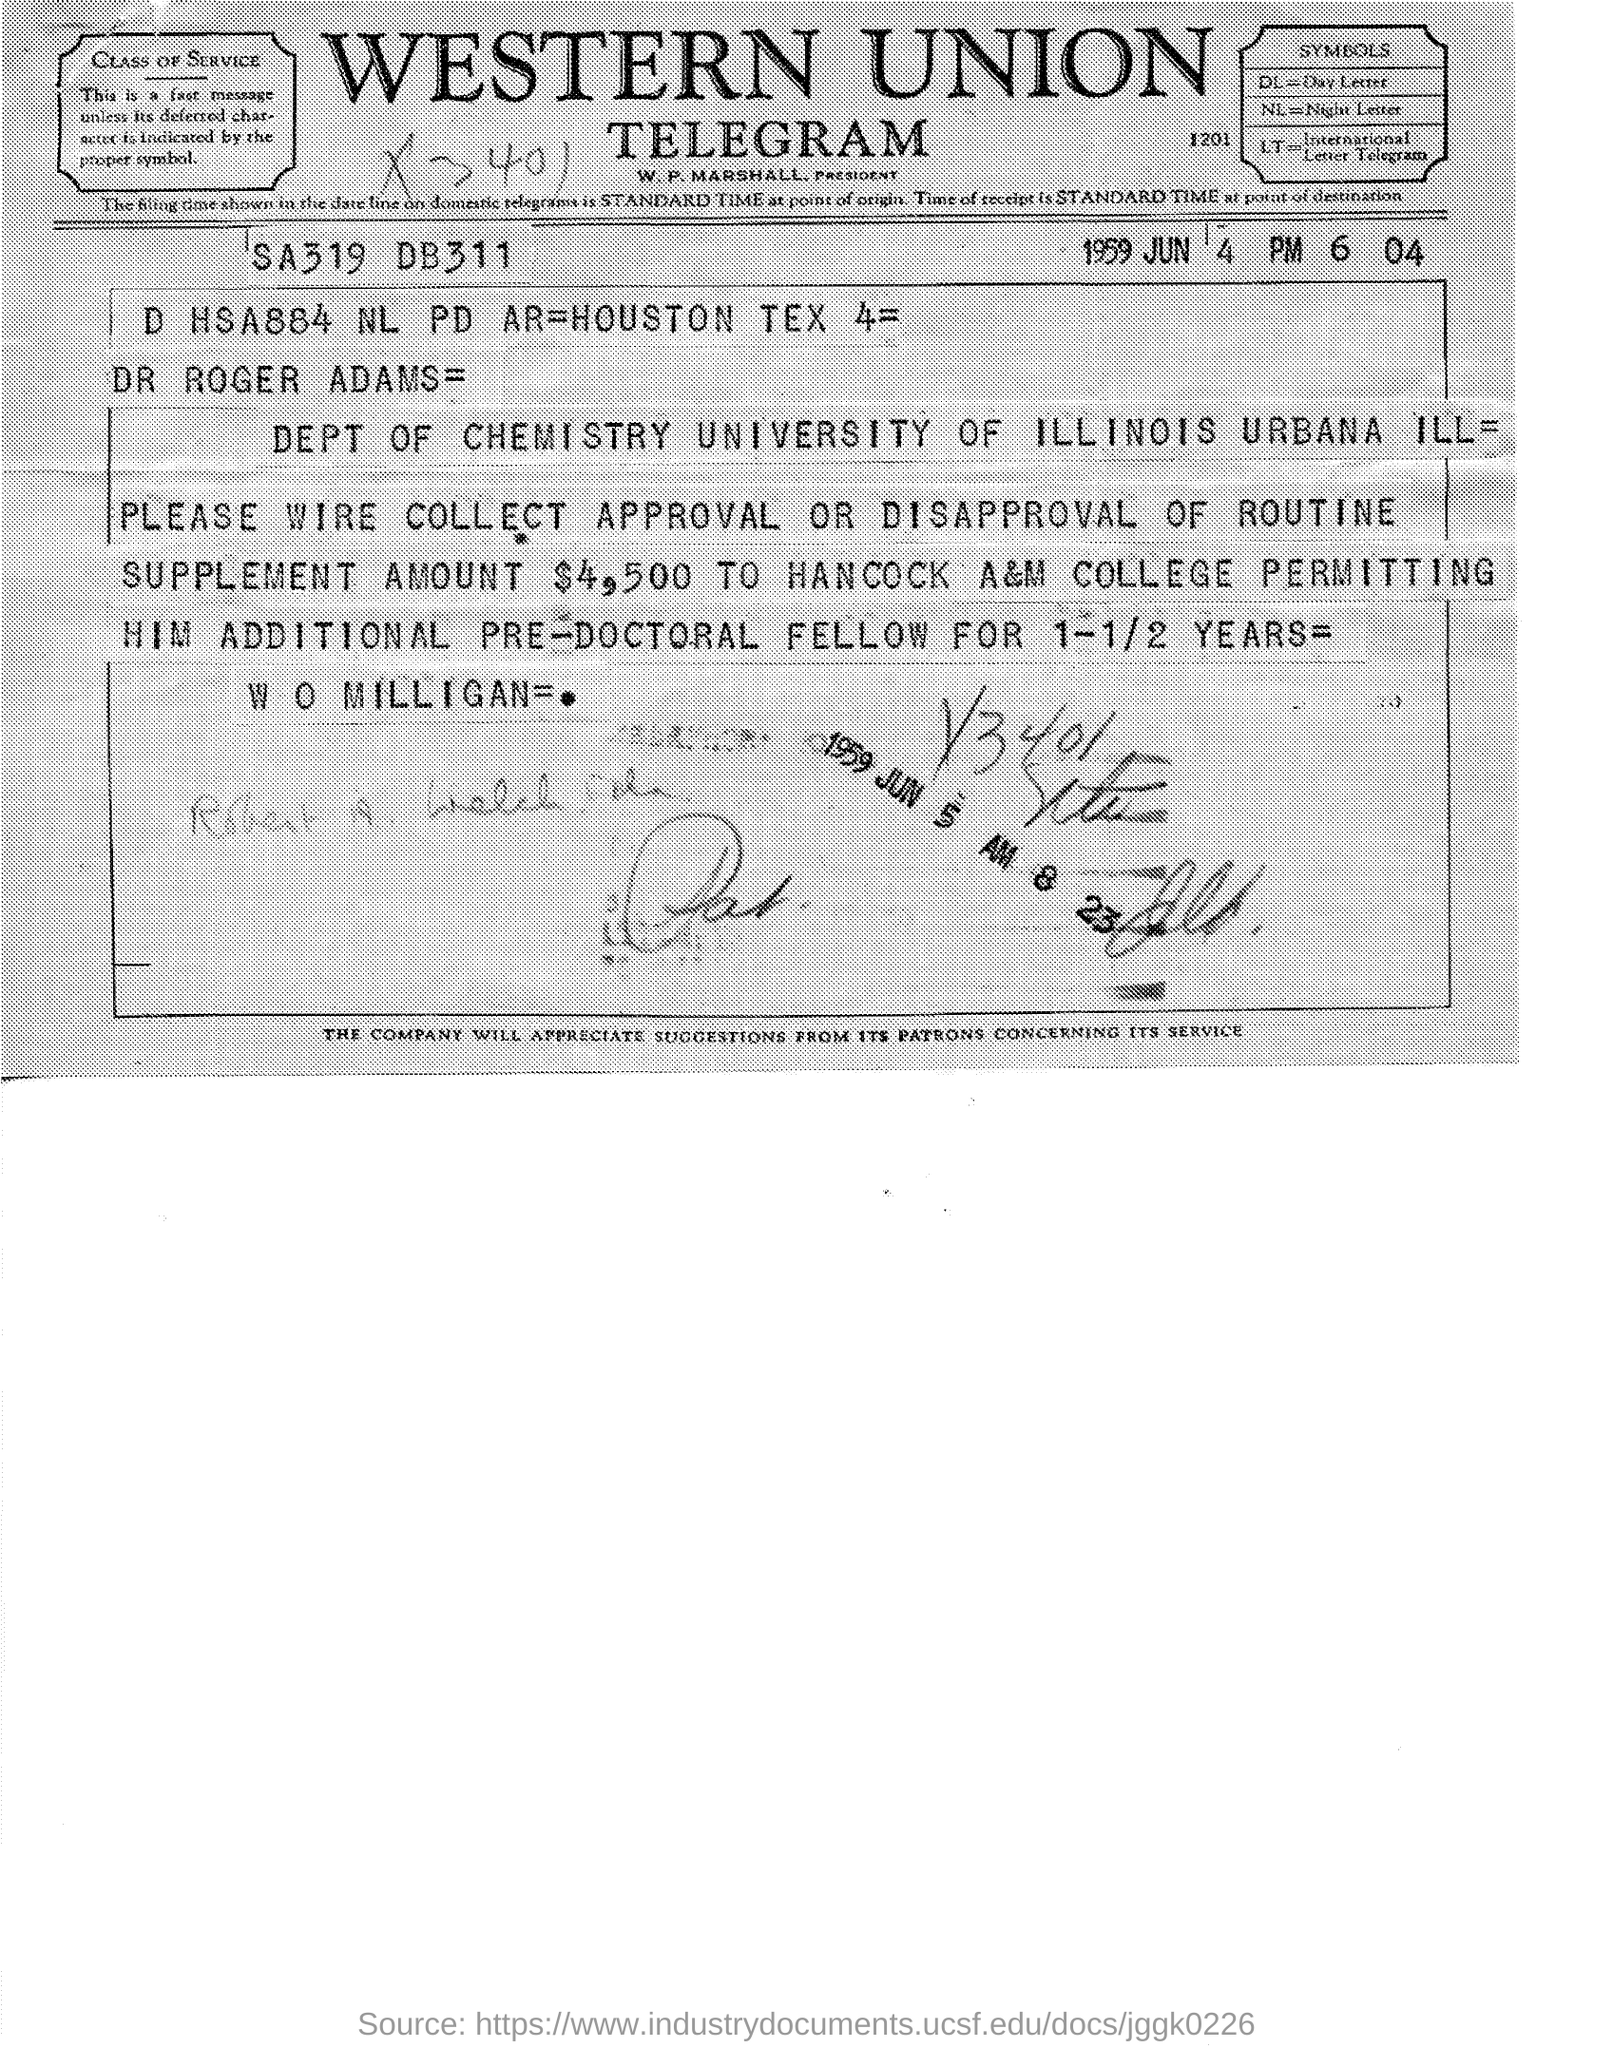Which firm is mentioned at the top of the page?
Offer a terse response. Western Union. When is the document dated?
Your answer should be compact. 1959 Jun 4. Which department is mentioned?
Keep it short and to the point. Dept of Chemistry. What is the routine supplement amount?
Your answer should be compact. $4,500. 